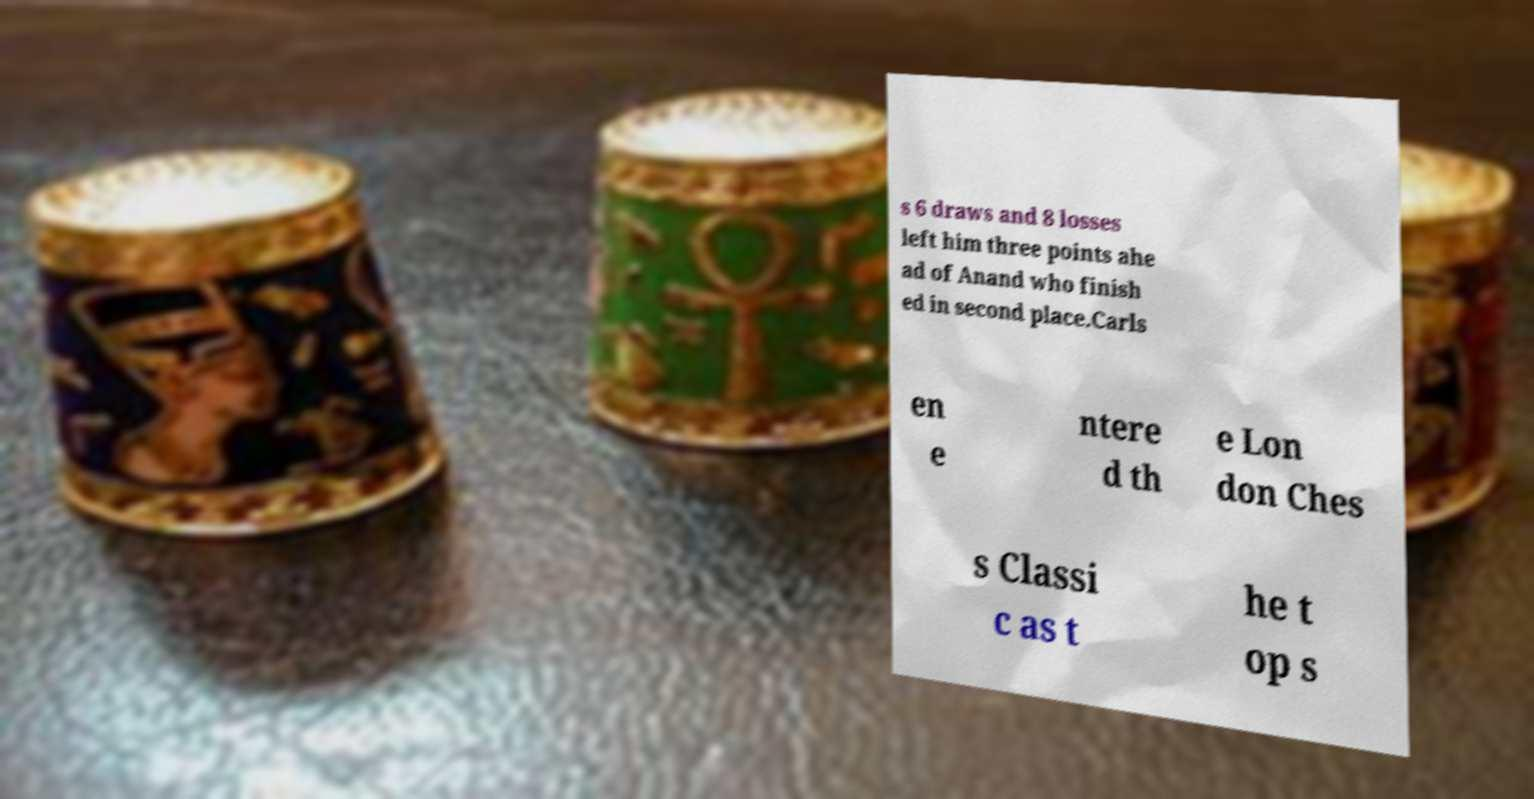There's text embedded in this image that I need extracted. Can you transcribe it verbatim? s 6 draws and 8 losses left him three points ahe ad of Anand who finish ed in second place.Carls en e ntere d th e Lon don Ches s Classi c as t he t op s 